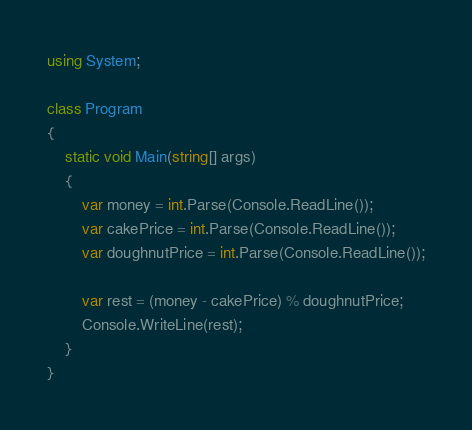Convert code to text. <code><loc_0><loc_0><loc_500><loc_500><_C#_>using System;

class Program
{
	static void Main(string[] args)
	{
		var money = int.Parse(Console.ReadLine());
		var cakePrice = int.Parse(Console.ReadLine());
		var doughnutPrice = int.Parse(Console.ReadLine());

		var rest = (money - cakePrice) % doughnutPrice;
		Console.WriteLine(rest);
	}
}</code> 